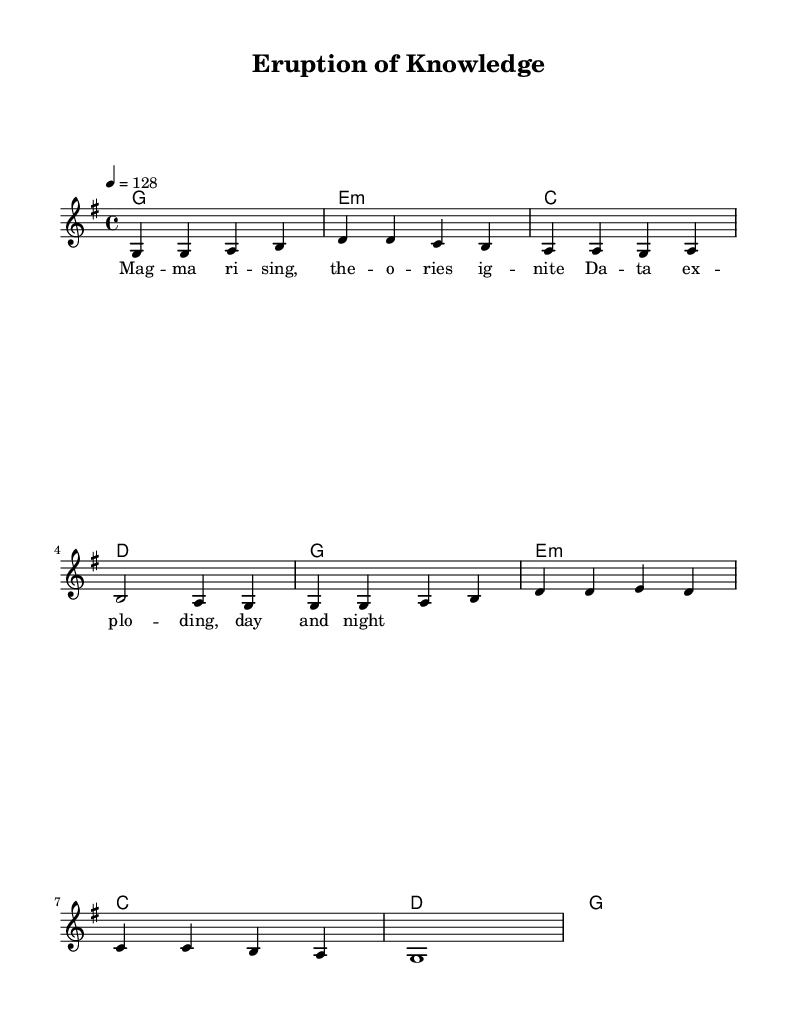What is the key signature of this music? The key signature is G major, which has one sharp (F#). This can be determined by looking at the key signature indicated at the beginning of the score.
Answer: G major What is the time signature of this music? The time signature is 4/4, which indicates that there are four beats in each measure and the quarter note gets one beat. This is typically indicated at the start of the score immediately after the key signature.
Answer: 4/4 What is the tempo marking of this music? The tempo marking is 128 beats per minute, as indicated by the text "4 = 128" at the start of the score. This informs the performer how fast to play the piece.
Answer: 128 How many measures are in the melody? By counting the distinct segments of notes separated by bar lines, there are a total of 8 measures in the melody. This reflects the structural format of the composition.
Answer: 8 What chord is played in the first measure? In the first measure, the chord played is G major, as shown by the chord name indicated above the staff in the first measure. This chord sets the foundation for the melody that follows.
Answer: G major What is the lyrical theme of the song? The lyrics suggest a theme related to scientific discoveries, with references to data and ignition of stories, indicating exploration and enthusiasm for knowledge. Lyrics can often reflect the subject matter the song is based on.
Answer: Scientific discoveries What type of musical structure is used here? The structure here resembles a verse form, which is common in K-Pop. This can be deduced from both the lyrical arrangement which conveys a narrative and the repetitive melodic phrases typical in pop music.
Answer: Verse form 